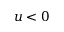<formula> <loc_0><loc_0><loc_500><loc_500>u < 0</formula> 